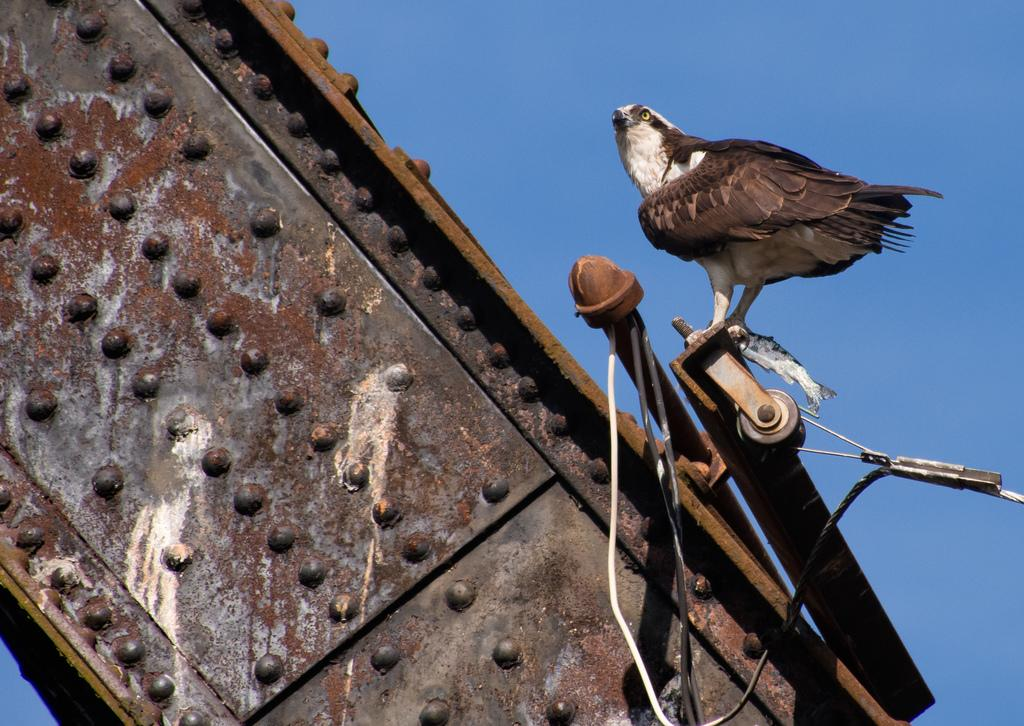What animal is the main subject of the image? There is an eagle in the image. What is the eagle standing on? The eagle is standing on a rod. What can be seen in the background of the image? The sky is visible in the background of the image. What type of memory is the eagle holding in its beak in the image? There is no memory present in the image; the eagle is standing on a rod with no objects in its beak. 